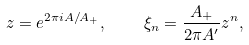<formula> <loc_0><loc_0><loc_500><loc_500>z = e ^ { 2 \pi i A / A _ { + } } , \quad \xi _ { n } = \frac { A _ { + } } { 2 \pi A ^ { \prime } } z ^ { n } ,</formula> 